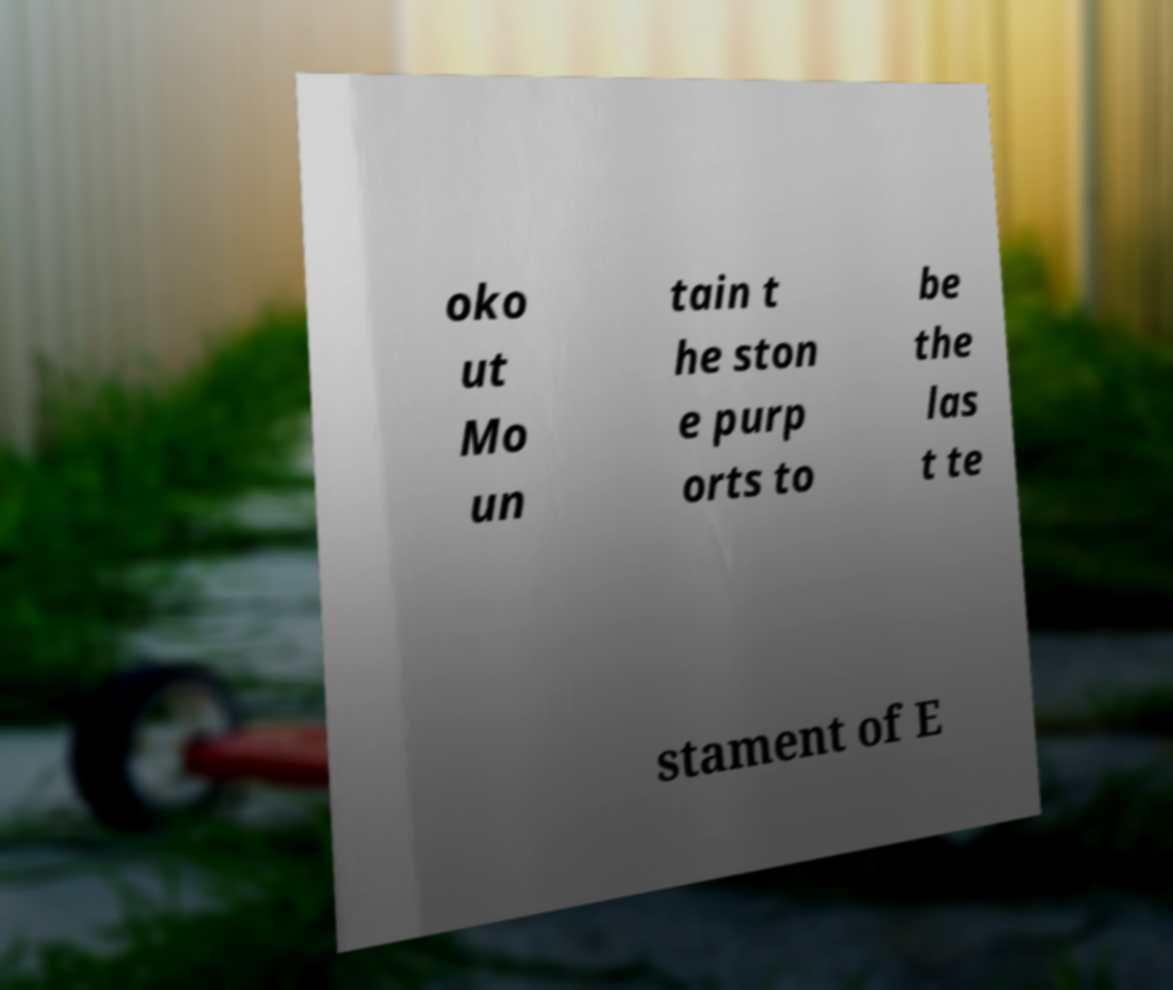Could you assist in decoding the text presented in this image and type it out clearly? oko ut Mo un tain t he ston e purp orts to be the las t te stament of E 